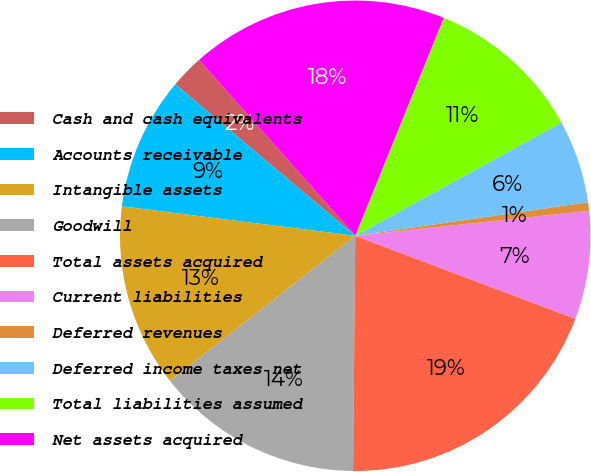Convert chart to OTSL. <chart><loc_0><loc_0><loc_500><loc_500><pie_chart><fcel>Cash and cash equivalents<fcel>Accounts receivable<fcel>Intangible assets<fcel>Goodwill<fcel>Total assets acquired<fcel>Current liabilities<fcel>Deferred revenues<fcel>Deferred income taxes net<fcel>Total liabilities assumed<fcel>Net assets acquired<nl><fcel>2.3%<fcel>9.14%<fcel>12.57%<fcel>14.28%<fcel>19.41%<fcel>7.43%<fcel>0.59%<fcel>5.72%<fcel>10.86%<fcel>17.7%<nl></chart> 